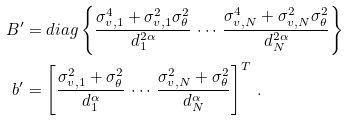<formula> <loc_0><loc_0><loc_500><loc_500>B ^ { \prime } & = d i a g \left \{ \frac { \sigma _ { v , 1 } ^ { 4 } + \sigma _ { v , 1 } ^ { 2 } \sigma _ { \theta } ^ { 2 } } { d _ { 1 } ^ { 2 \alpha } } \, \cdots \, \frac { \sigma _ { v , N } ^ { 4 } + \sigma _ { v , N } ^ { 2 } \sigma _ { \theta } ^ { 2 } } { d _ { N } ^ { 2 \alpha } } \right \} \\ b ^ { \prime } & = \left [ \frac { \sigma _ { v , 1 } ^ { 2 } + \sigma _ { \theta } ^ { 2 } } { d _ { 1 } ^ { \alpha } } \, \cdots \, \frac { \sigma _ { v , N } ^ { 2 } + \sigma _ { \theta } ^ { 2 } } { d _ { N } ^ { \alpha } } \right ] ^ { T } \, .</formula> 